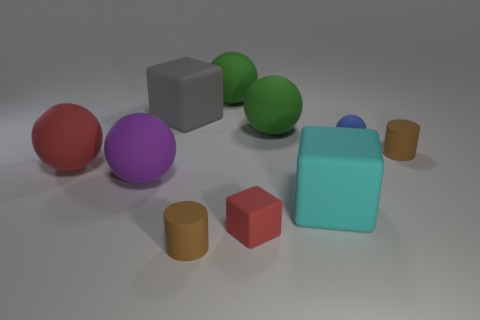What color is the cylinder that is to the left of the tiny rubber ball?
Ensure brevity in your answer.  Brown. Are there fewer large cyan cubes that are to the left of the gray thing than large brown matte balls?
Provide a short and direct response. No. There is a thing that is the same color as the small block; what is its size?
Offer a terse response. Large. Is the big cyan cube made of the same material as the purple ball?
Keep it short and to the point. Yes. What number of objects are big things on the right side of the tiny rubber block or big objects to the left of the red cube?
Offer a terse response. 6. Is there a brown metallic sphere of the same size as the purple rubber sphere?
Offer a very short reply. No. What color is the other tiny rubber thing that is the same shape as the gray thing?
Keep it short and to the point. Red. Is there a green rubber thing left of the tiny brown rubber thing right of the small blue rubber thing?
Your answer should be very brief. Yes. There is a red rubber object in front of the big red matte object; does it have the same shape as the big gray object?
Offer a very short reply. Yes. There is a purple matte object; what shape is it?
Offer a very short reply. Sphere. 